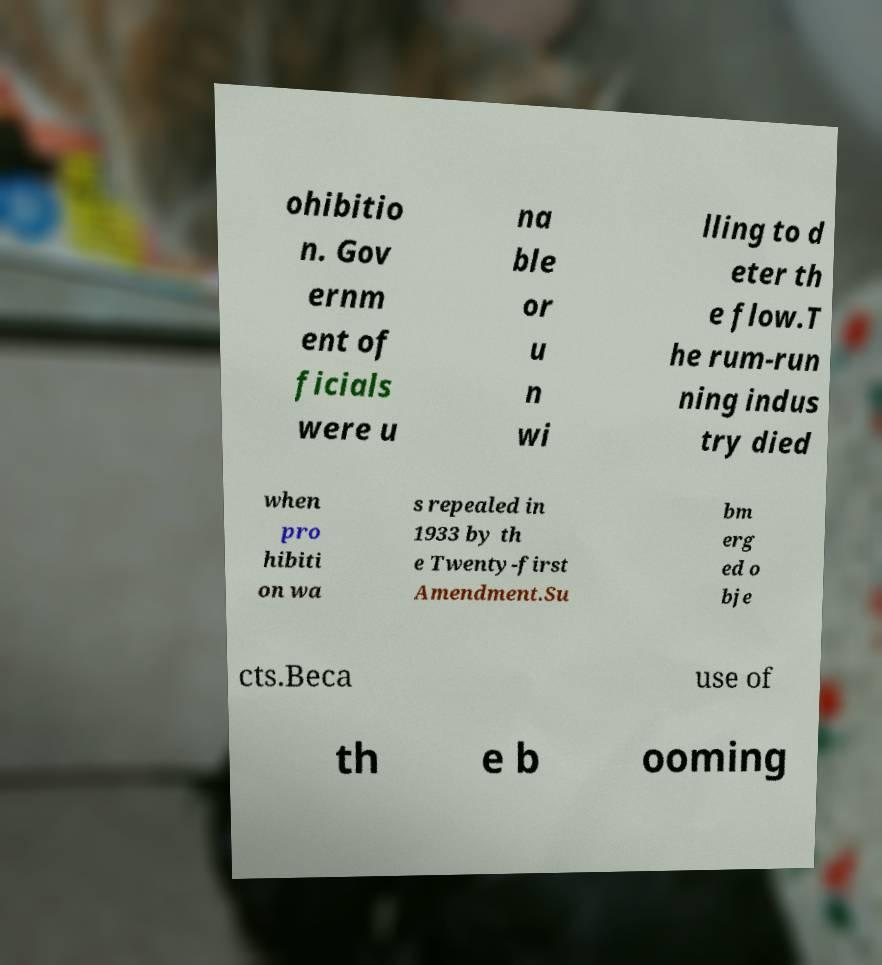Please read and relay the text visible in this image. What does it say? ohibitio n. Gov ernm ent of ficials were u na ble or u n wi lling to d eter th e flow.T he rum-run ning indus try died when pro hibiti on wa s repealed in 1933 by th e Twenty-first Amendment.Su bm erg ed o bje cts.Beca use of th e b ooming 